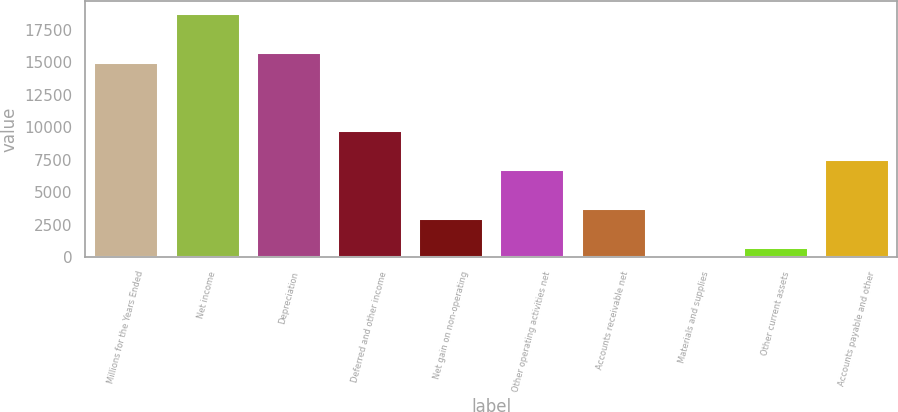Convert chart. <chart><loc_0><loc_0><loc_500><loc_500><bar_chart><fcel>Millions for the Years Ended<fcel>Net income<fcel>Depreciation<fcel>Deferred and other income<fcel>Net gain on non-operating<fcel>Other operating activities net<fcel>Accounts receivable net<fcel>Materials and supplies<fcel>Other current assets<fcel>Accounts payable and other<nl><fcel>15031<fcel>18784<fcel>15781.6<fcel>9776.8<fcel>3021.4<fcel>6774.4<fcel>3772<fcel>19<fcel>769.6<fcel>7525<nl></chart> 